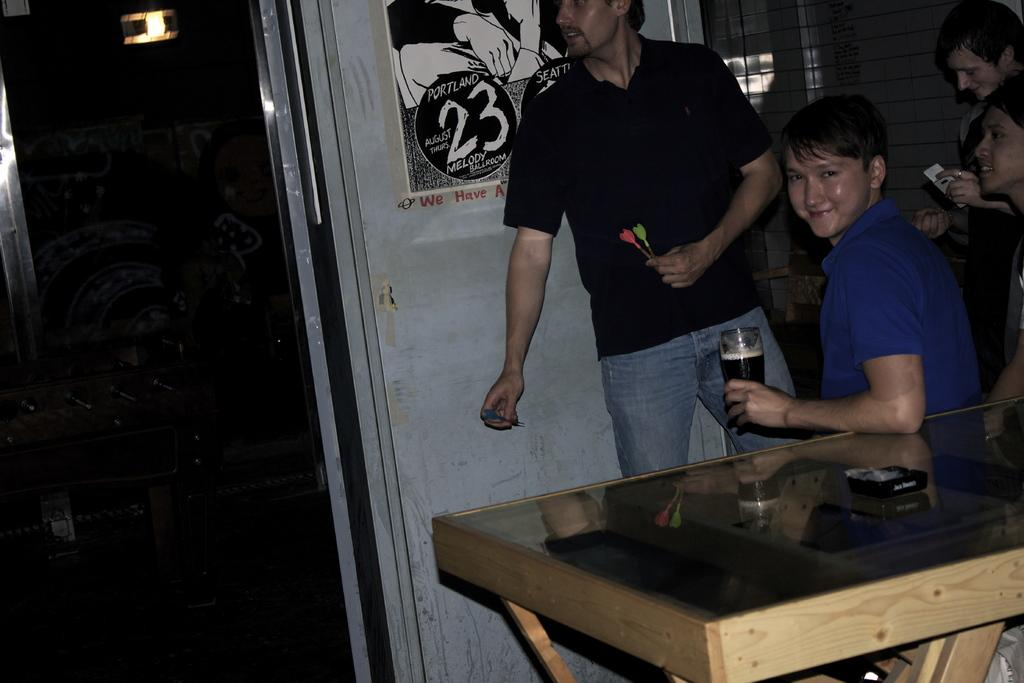How many people are present in the image? There are four people in the image, two sitting on chairs and two standing. What is the furniture present in the image? There is a table in the image. What can be seen in the background of the image? There is a white color wall, a window, and a poster in the background. What type of silver glove is being used by the person in the image? There is no silver glove present in the image. Can you see any sail-related objects in the image? There are no sail-related objects visible in the image. 